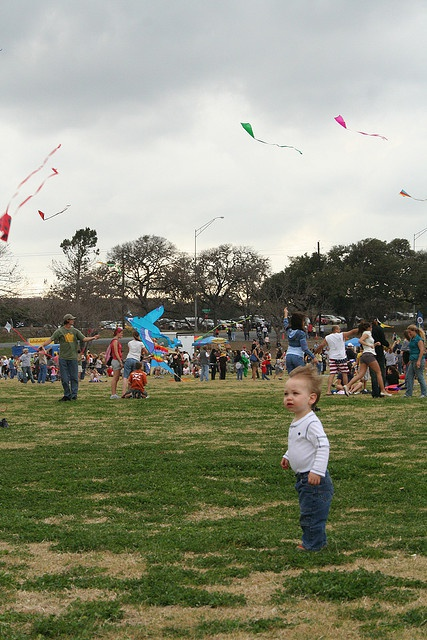Describe the objects in this image and their specific colors. I can see people in lightgray, black, and gray tones, people in lightgray, black, darkgray, lavender, and olive tones, people in lightgray, black, gray, and darkgreen tones, people in lightgray, black, teal, and gray tones, and people in lightgray, lavender, darkgray, gray, and maroon tones in this image. 